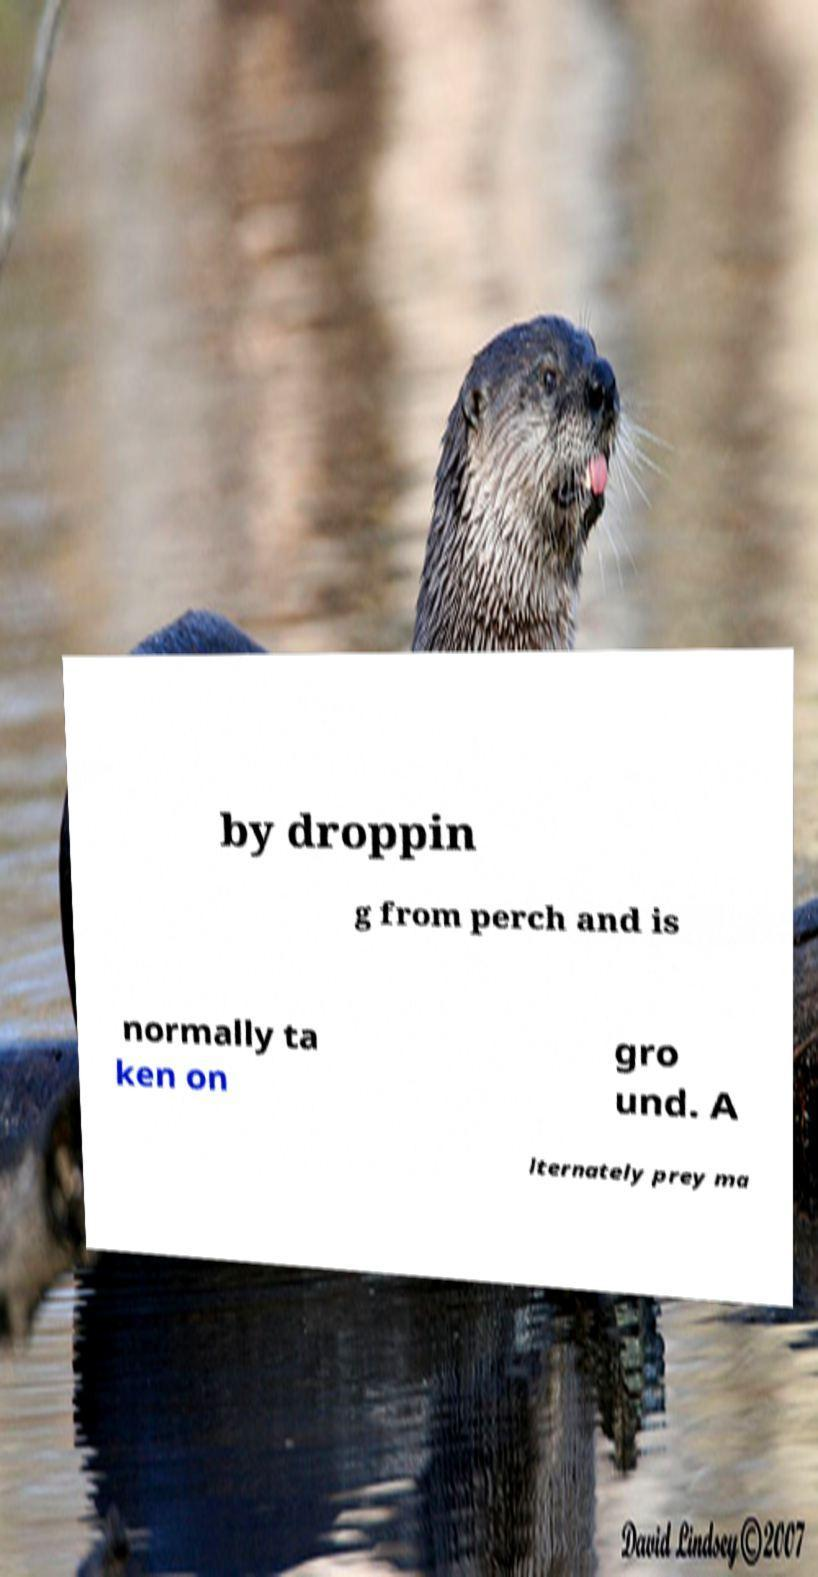There's text embedded in this image that I need extracted. Can you transcribe it verbatim? by droppin g from perch and is normally ta ken on gro und. A lternately prey ma 